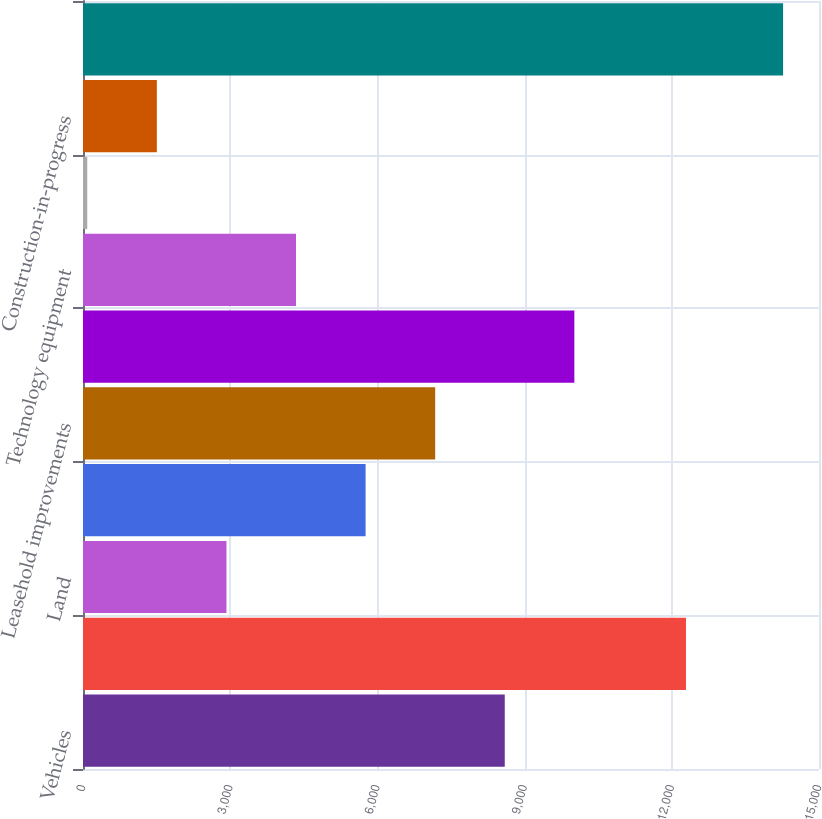<chart> <loc_0><loc_0><loc_500><loc_500><bar_chart><fcel>Vehicles<fcel>Aircraft (including aircraft<fcel>Land<fcel>Buildings<fcel>Leasehold improvements<fcel>Plant equipment<fcel>Technology equipment<fcel>Equipment under operating<fcel>Construction-in-progress<fcel>Less Accumulated depreciation<nl><fcel>8595.6<fcel>12289<fcel>2923.2<fcel>5759.4<fcel>7177.5<fcel>10013.7<fcel>4341.3<fcel>87<fcel>1505.1<fcel>14268<nl></chart> 